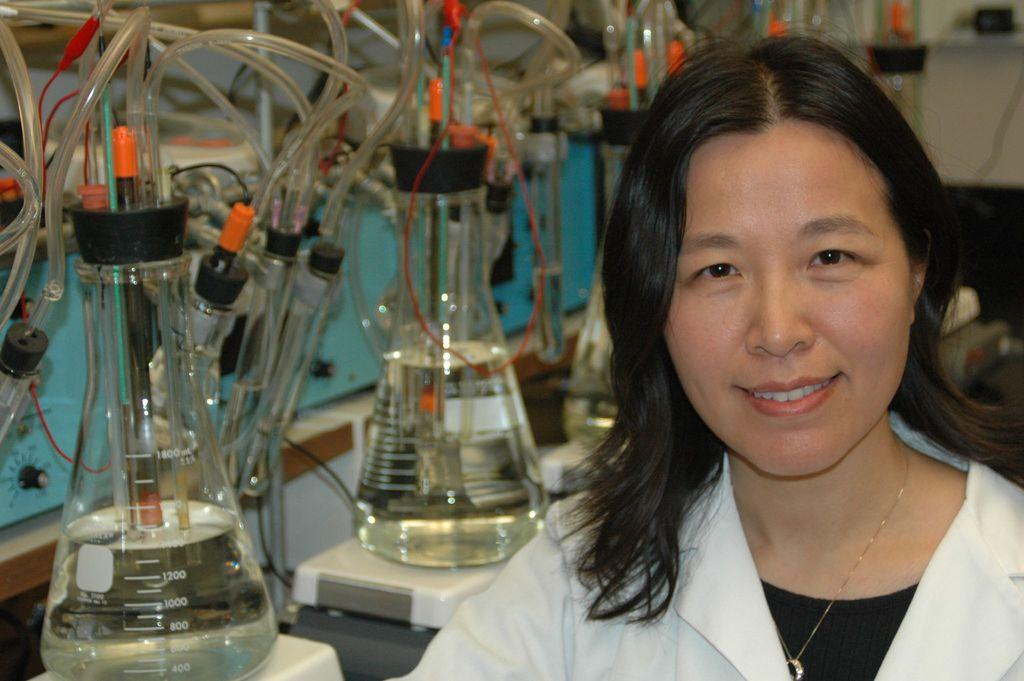Who is present in the image? There is a woman in the image. What is the woman wearing? The woman is wearing a white jacket. On which side of the image is the woman located? The woman is on the right side of the image. What type of objects can be seen in the image? There are glass flasks and pipes in the image. What type of cake is the queen holding in the image? There is no queen or cake present in the image; it features a woman wearing a white jacket and other objects. 